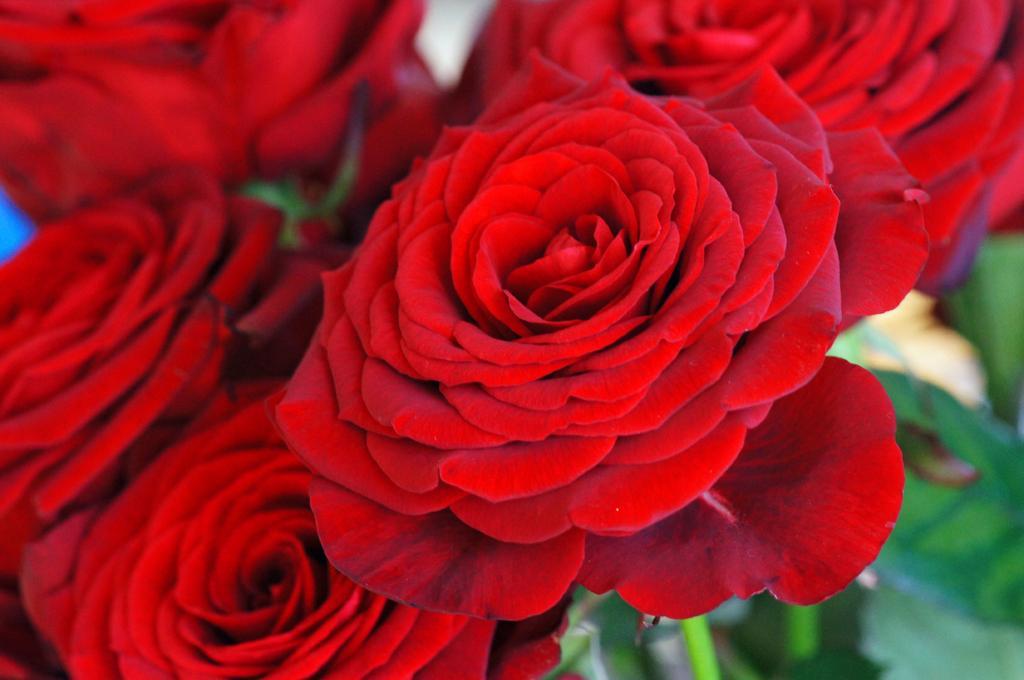Describe this image in one or two sentences. In this image we can see a bunch of rose flowers. 